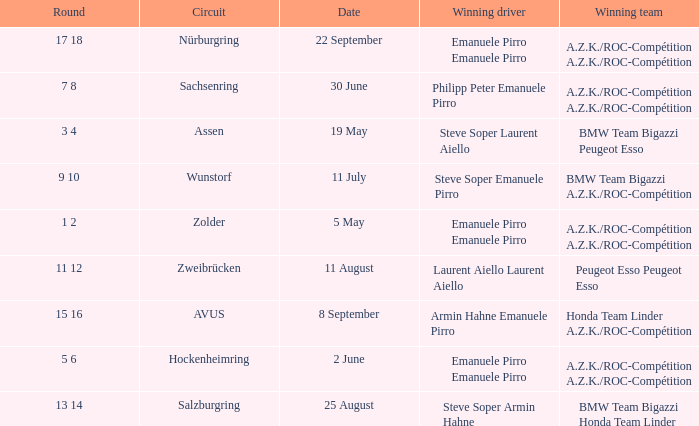What is the date of the zolder circuit, which had a.z.k./roc-compétition a.z.k./roc-compétition as the winning team? 5 May. 